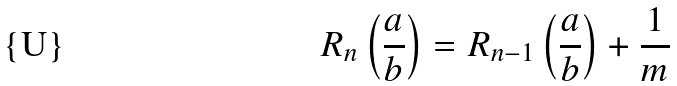<formula> <loc_0><loc_0><loc_500><loc_500>R _ { n } \left ( \frac { a } { b } \right ) = R _ { n - 1 } \left ( \frac { a } { b } \right ) + \frac { 1 } { m }</formula> 